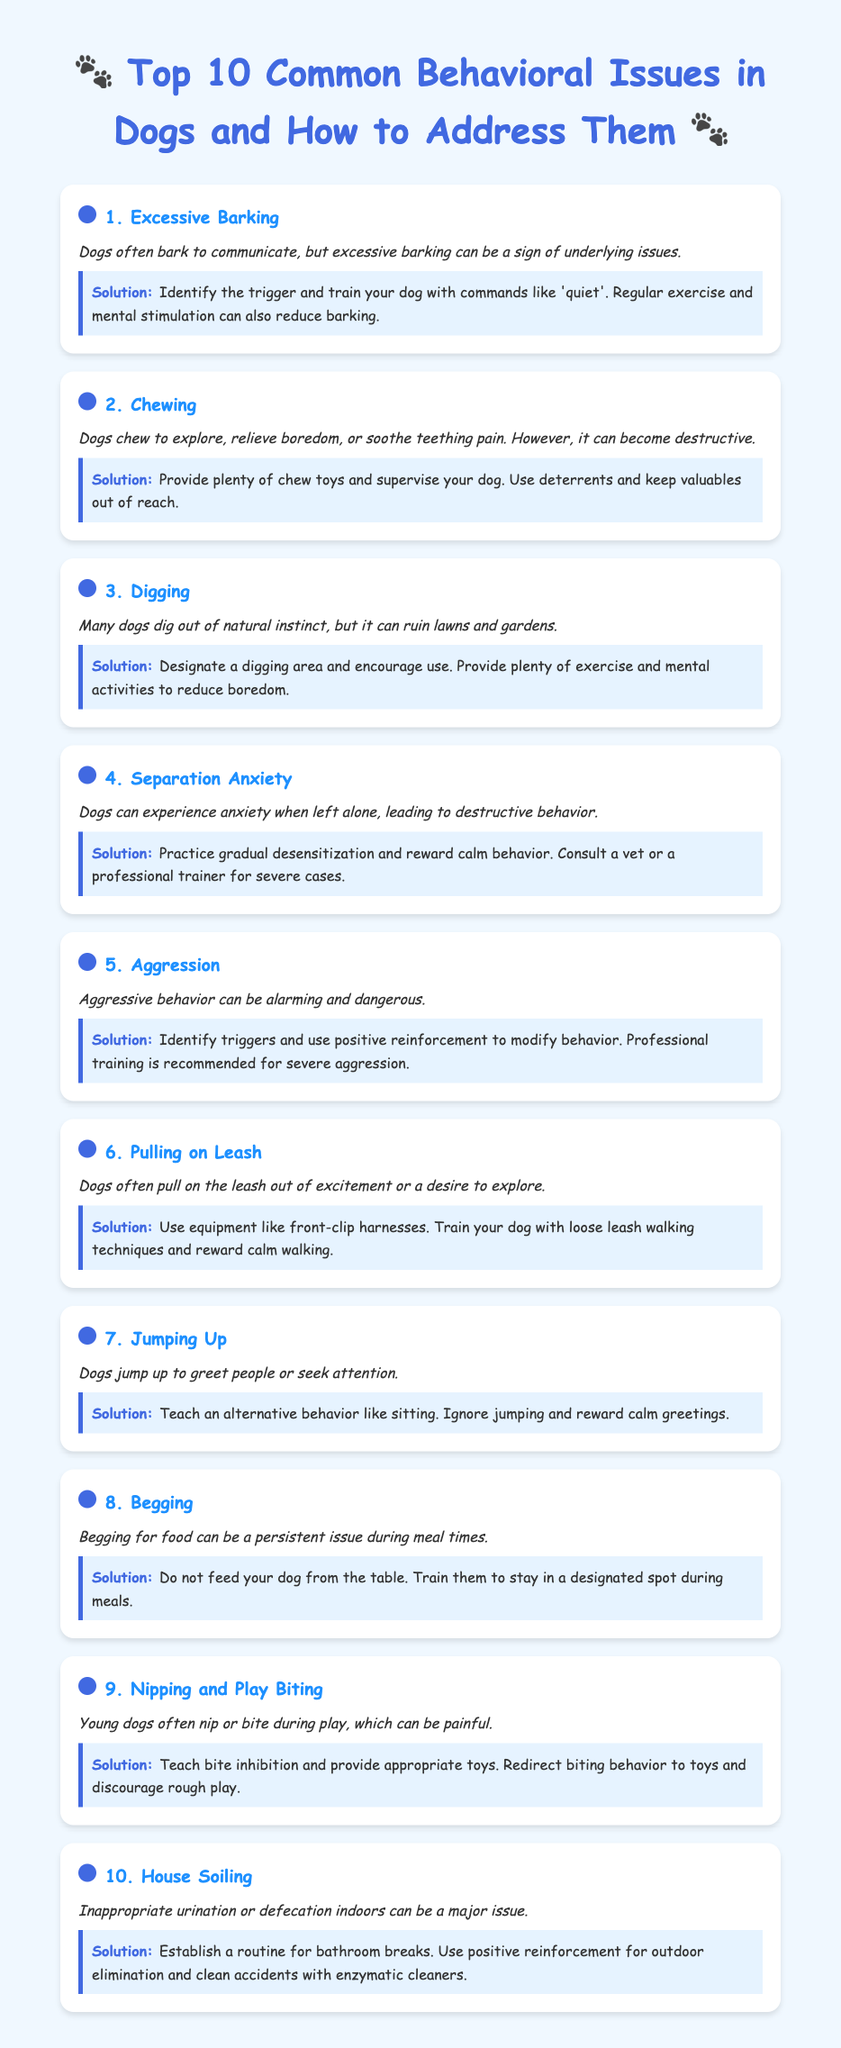What is the first behavioral issue listed? The first issue listed in the document is "Excessive Barking".
Answer: Excessive Barking How many behavioral issues are addressed in the document? The document lists a total of 10 behavioral issues.
Answer: 10 What is a recommended solution for excessive barking? The document suggests identifying the trigger and training your dog with commands like 'quiet'.
Answer: Identify the trigger and train with 'quiet' What behavior does dog jumping up correspond to? Jumping up is associated with dogs greeting people or seeking attention.
Answer: Greeting or seeking attention What is the suggested action for managing separation anxiety? The document recommends practicing gradual desensitization and rewarding calm behavior.
Answer: Gradual desensitization and reward calm behavior What type of harness is recommended for pulling on leash? The document recommends using front-clip harnesses for dogs that pull on the leash.
Answer: Front-clip harnesses How should house soiling be addressed? Establishing a routine for bathroom breaks is suggested to manage house soiling.
Answer: Establish a routine for bathroom breaks What is the cause of digging behavior in dogs? Digging often results from a dog's natural instinct.
Answer: Natural instinct What training method is recommended for nipping and play biting? Teaching bite inhibition is recommended for nipping and play biting.
Answer: Teach bite inhibition What behavior does begging refer to during meal times? Begging refers to dogs asking for food during meal times.
Answer: Asking for food during meal times 